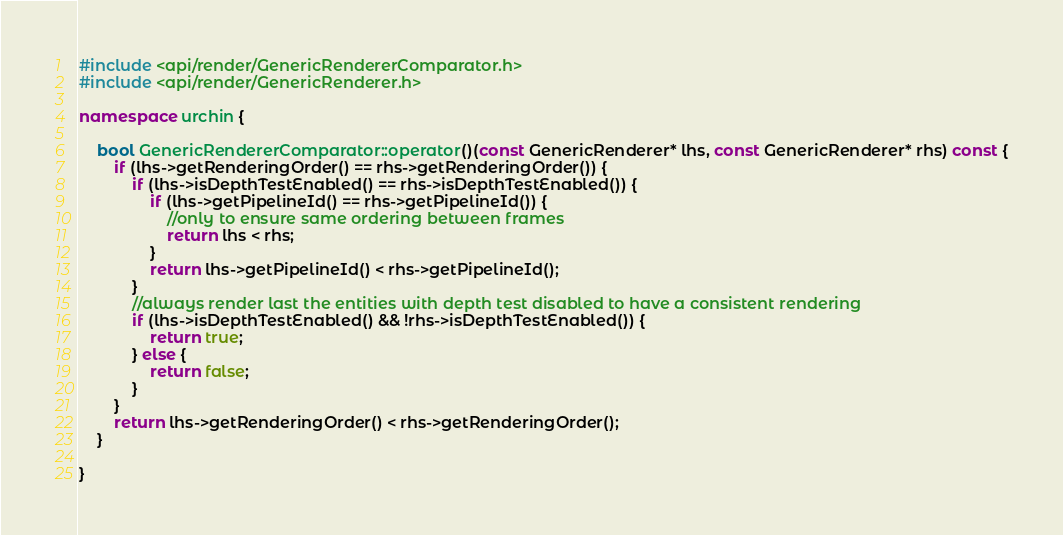Convert code to text. <code><loc_0><loc_0><loc_500><loc_500><_C++_>#include <api/render/GenericRendererComparator.h>
#include <api/render/GenericRenderer.h>

namespace urchin {

    bool GenericRendererComparator::operator()(const GenericRenderer* lhs, const GenericRenderer* rhs) const {
        if (lhs->getRenderingOrder() == rhs->getRenderingOrder()) {
            if (lhs->isDepthTestEnabled() == rhs->isDepthTestEnabled()) {
                if (lhs->getPipelineId() == rhs->getPipelineId()) {
                    //only to ensure same ordering between frames
                    return lhs < rhs;
                }
                return lhs->getPipelineId() < rhs->getPipelineId();
            }
            //always render last the entities with depth test disabled to have a consistent rendering
            if (lhs->isDepthTestEnabled() && !rhs->isDepthTestEnabled()) {
                return true;
            } else {
                return false;
            }
        }
        return lhs->getRenderingOrder() < rhs->getRenderingOrder();
    }

}</code> 